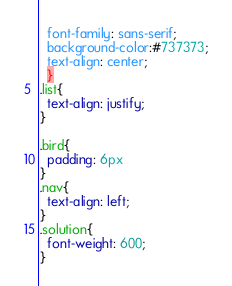<code> <loc_0><loc_0><loc_500><loc_500><_CSS_>  font-family: sans-serif;
  background-color:#737373;
  text-align: center;
  }
.list{
  text-align: justify;
}

.bird{
  padding: 6px
}
.nav{
  text-align: left;
}
.solution{
  font-weight: 600;
}
</code> 